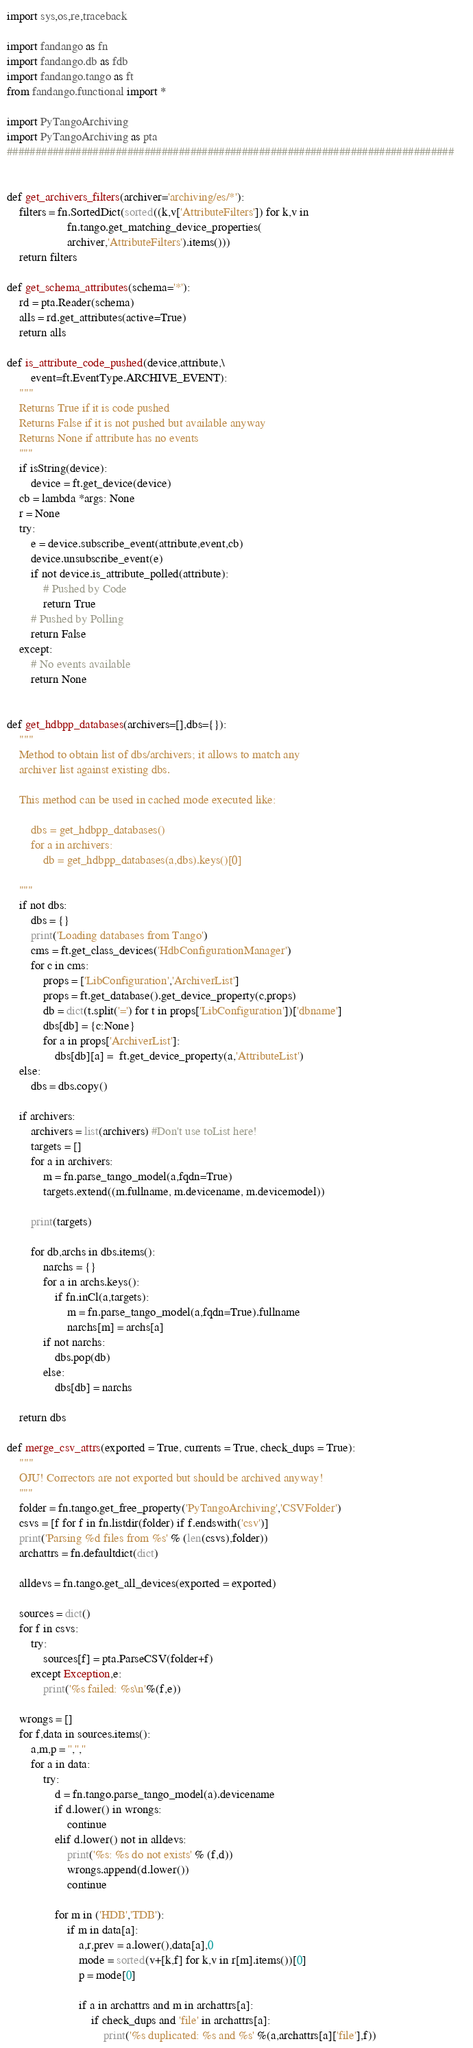Convert code to text. <code><loc_0><loc_0><loc_500><loc_500><_Python_>import sys,os,re,traceback

import fandango as fn
import fandango.db as fdb
import fandango.tango as ft
from fandango.functional import *

import PyTangoArchiving
import PyTangoArchiving as pta
##############################################################################    

   
def get_archivers_filters(archiver='archiving/es/*'):
    filters = fn.SortedDict(sorted((k,v['AttributeFilters']) for k,v in 
                    fn.tango.get_matching_device_properties(
                    archiver,'AttributeFilters').items()))
    return filters

def get_schema_attributes(schema='*'):
    rd = pta.Reader(schema)
    alls = rd.get_attributes(active=True)
    return alls

def is_attribute_code_pushed(device,attribute,\
        event=ft.EventType.ARCHIVE_EVENT):
    """
    Returns True if it is code pushed
    Returns False if it is not pushed but available anyway
    Returns None if attribute has no events
    """
    if isString(device): 
        device = ft.get_device(device)
    cb = lambda *args: None
    r = None
    try:
        e = device.subscribe_event(attribute,event,cb)
        device.unsubscribe_event(e)
        if not device.is_attribute_polled(attribute):
            # Pushed by Code
            return True
        # Pushed by Polling
        return False
    except:
        # No events available
        return None
        

def get_hdbpp_databases(archivers=[],dbs={}):
    """
    Method to obtain list of dbs/archivers; it allows to match any 
    archiver list against existing dbs.
    
    This method can be used in cached mode executed like:
    
        dbs = get_hdbpp_databases()
        for a in archivers:
            db = get_hdbpp_databases(a,dbs).keys()[0]
      
    """
    if not dbs:
        dbs = {}
        print('Loading databases from Tango')
        cms = ft.get_class_devices('HdbConfigurationManager')
        for c in cms:
            props = ['LibConfiguration','ArchiverList']
            props = ft.get_database().get_device_property(c,props)
            db = dict(t.split('=') for t in props['LibConfiguration'])['dbname']
            dbs[db] = {c:None}
            for a in props['ArchiverList']:
                dbs[db][a] =  ft.get_device_property(a,'AttributeList')
    else:
        dbs = dbs.copy()
            
    if archivers:
        archivers = list(archivers) #Don't use toList here!
        targets = []
        for a in archivers:
            m = fn.parse_tango_model(a,fqdn=True)
            targets.extend((m.fullname, m.devicename, m.devicemodel))
            
        print(targets)

        for db,archs in dbs.items():
            narchs = {}
            for a in archs.keys():
                if fn.inCl(a,targets):
                    m = fn.parse_tango_model(a,fqdn=True).fullname
                    narchs[m] = archs[a]
            if not narchs:
                dbs.pop(db)
            else:
                dbs[db] = narchs
            
    return dbs

def merge_csv_attrs(exported = True, currents = True, check_dups = True):
    """
    OJU! Correctors are not exported but should be archived anyway!
    """
    folder = fn.tango.get_free_property('PyTangoArchiving','CSVFolder')
    csvs = [f for f in fn.listdir(folder) if f.endswith('csv')]
    print('Parsing %d files from %s' % (len(csvs),folder))
    archattrs = fn.defaultdict(dict)

    alldevs = fn.tango.get_all_devices(exported = exported)
    
    sources = dict()
    for f in csvs:
        try:
            sources[f] = pta.ParseCSV(folder+f)
        except Exception,e:
            print('%s failed: %s\n'%(f,e))
    
    wrongs = []
    for f,data in sources.items():
        a,m,p = '','',''
        for a in data:
            try:
                d = fn.tango.parse_tango_model(a).devicename
                if d.lower() in wrongs: 
                    continue
                elif d.lower() not in alldevs:
                    print('%s: %s do not exists' % (f,d))
                    wrongs.append(d.lower())
                    continue
                
                for m in ('HDB','TDB'):
                    if m in data[a]:
                        a,r,prev = a.lower(),data[a],0
                        mode = sorted(v+[k,f] for k,v in r[m].items())[0]
                        p = mode[0]
                        
                        if a in archattrs and m in archattrs[a]:
                            if check_dups and 'file' in archattrs[a]:
                                print('%s duplicated: %s and %s' %(a,archattrs[a]['file'],f))</code> 